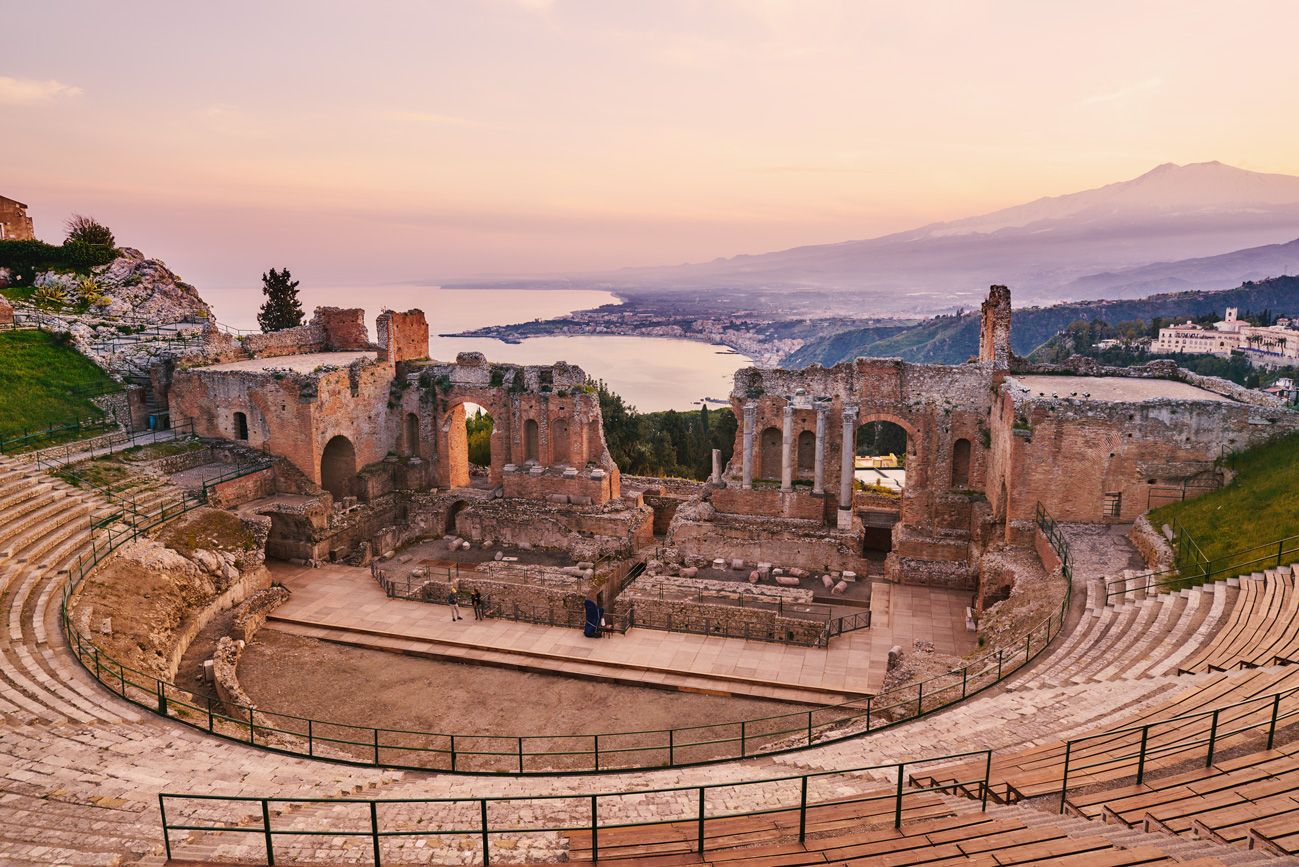Can you tell me more about the history of this theater? Certainly! The Greek theater of Taormina was built in the 3rd century BCE. It is renowned for its remarkable preservation and the stunning natural backdrop it offers. The theater was originally used for dramatic and musical performances, and due to its strategic location, it also served as an assembly place for the local population to discuss community matters. Later, the Romans expanded and adapted it for gladiatorial games. Today, it's a popular tourist destination and serves as a venue for various cultural events, including an annual arts festival. 